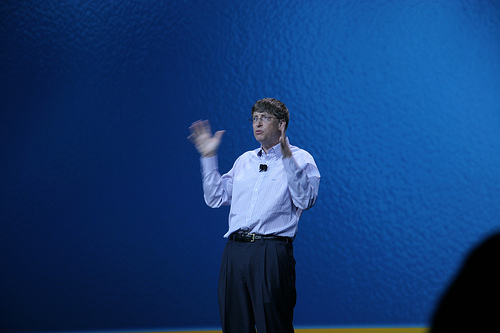<image>
Is there a man on the wall? No. The man is not positioned on the wall. They may be near each other, but the man is not supported by or resting on top of the wall. 